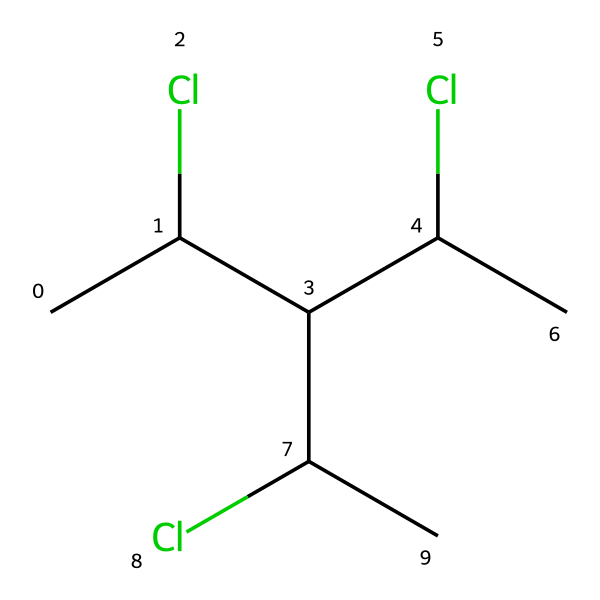how many carbon atoms are in this chemical? The SMILES representation includes four carbon atoms, as indicated by the "C" characters. Each "C" represents a carbon atom in the structure, and there are no other characters that correspond to additional carbon atoms.
Answer: four how many chlorine atoms are present in the structure? In the given SMILES, there are three "Cl" notations, indicating the presence of three chlorine atoms attached to the carbon backbone.
Answer: three what type of polymer is represented by this SMILES? The presence of chlorine atoms attached to a carbon chain characterizes this compound as polyvinyl chloride (PVC), which is a type of vinyl polymer. The "C" and "Cl" elements mark it clearly as PVC.
Answer: polyvinyl chloride how does the presence of chlorine affect the properties of this material? The chlorine atoms in PVC increase its chemical stability and resistance to heat compared to other polymers. This addition creates stronger intermolecular forces, affecting durability and flexibility.
Answer: increases stability is this chemical soluble in water? PVC is known to be insoluble in water due to its strong carbon-chlorine bonds and hydrophobic character, which prevents it from interacting with water molecules effectively.
Answer: insoluble what is one major application of this polymer in medical contexts? PVC is commonly used in medical tubing due to its flexibility, durability, and resistance to various chemicals, making it suitable for various medical equipment.
Answer: medical tubing how does PVC compare to other plastics in terms of toxicological concerns? PVC has been associated with higher toxicological concerns due to the potential release of harmful substances like dioxins upon burning and the use of plasticizers, which may leach out. This contrasts with other plastics that may have lower risks.
Answer: higher toxicological concerns 